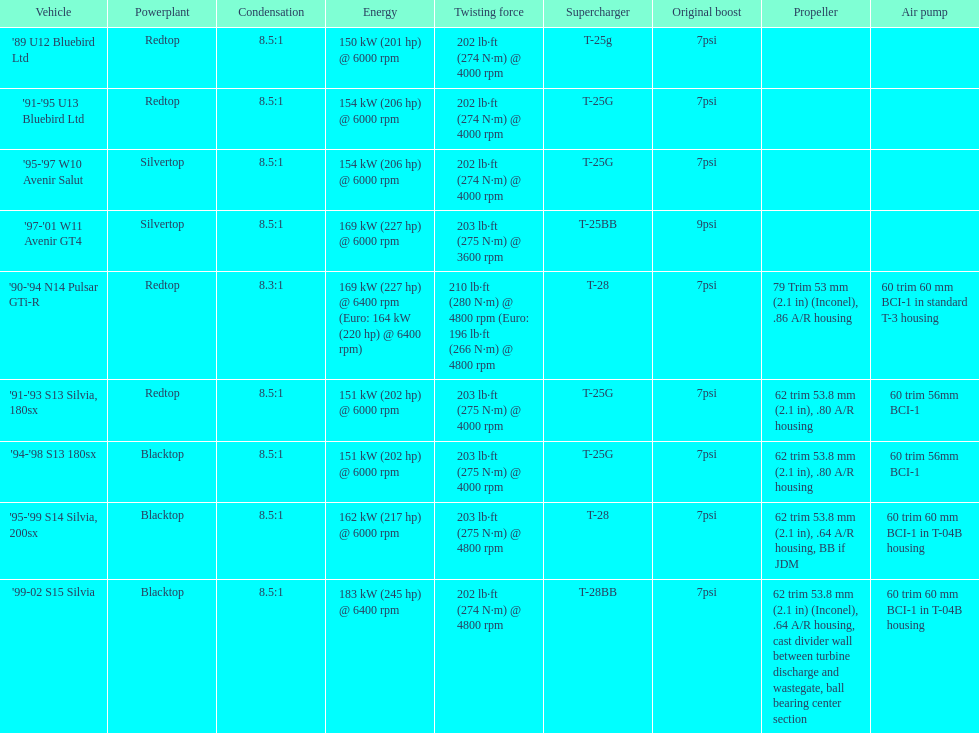What is his/her compression for the 90-94 n14 pulsar gti-r? 8.3:1. 